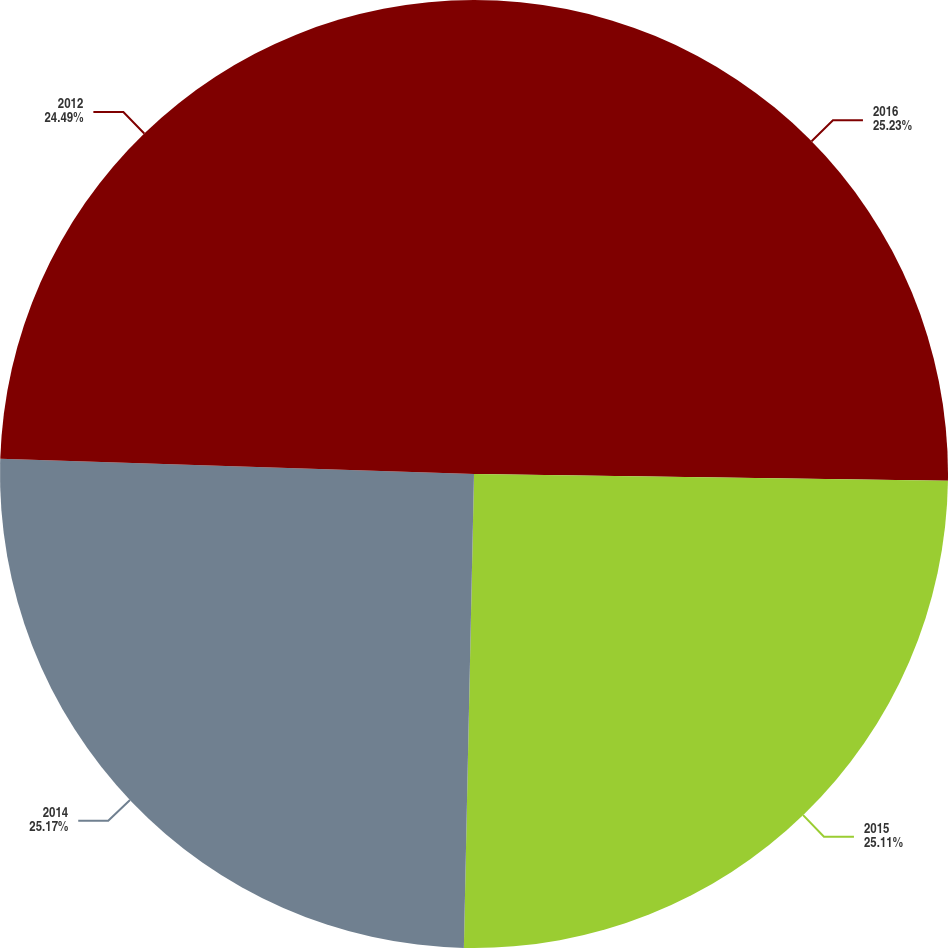Convert chart to OTSL. <chart><loc_0><loc_0><loc_500><loc_500><pie_chart><fcel>2016<fcel>2015<fcel>2014<fcel>2012<nl><fcel>25.23%<fcel>25.11%<fcel>25.17%<fcel>24.49%<nl></chart> 